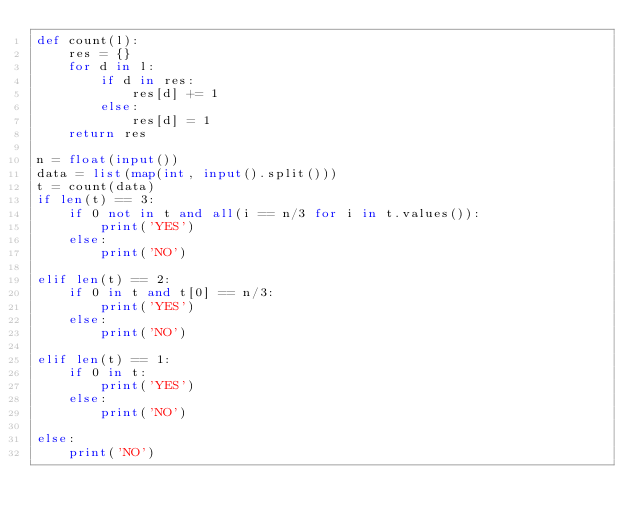<code> <loc_0><loc_0><loc_500><loc_500><_Python_>def count(l):
    res = {}
    for d in l:
        if d in res:
            res[d] += 1
        else:
            res[d] = 1
    return res

n = float(input())
data = list(map(int, input().split()))
t = count(data)
if len(t) == 3:
    if 0 not in t and all(i == n/3 for i in t.values()):
        print('YES')
    else:
        print('NO')

elif len(t) == 2:
    if 0 in t and t[0] == n/3:
        print('YES')
    else:
        print('NO')

elif len(t) == 1:
    if 0 in t:
        print('YES')
    else:
        print('NO')

else:
    print('NO')
        
</code> 